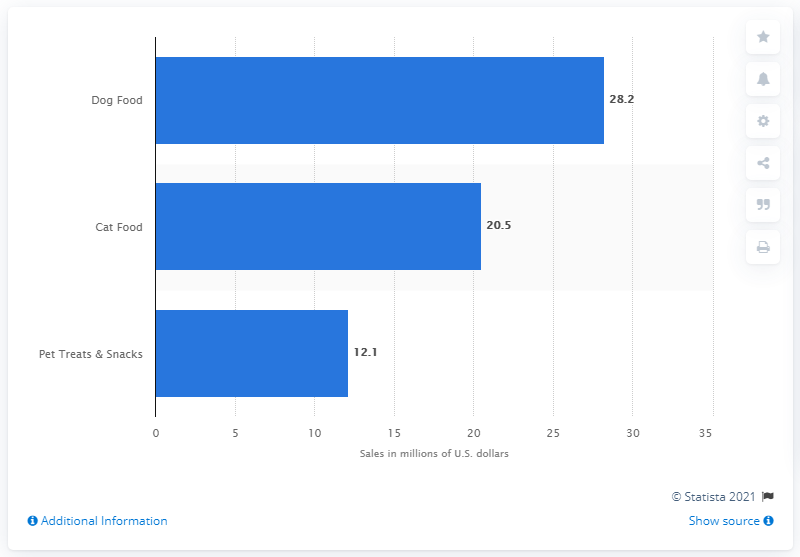Indicate a few pertinent items in this graphic. The retail sales of dog food in 2014 were approximately $28.2 billion. According to data from 2014, the retail dollar sales of dog food was 28.2 billion dollars. 